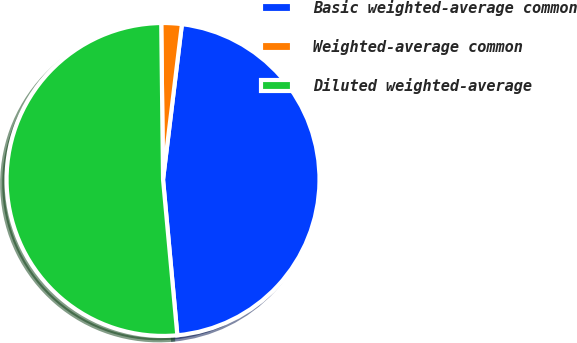Convert chart to OTSL. <chart><loc_0><loc_0><loc_500><loc_500><pie_chart><fcel>Basic weighted-average common<fcel>Weighted-average common<fcel>Diluted weighted-average<nl><fcel>46.61%<fcel>2.11%<fcel>51.27%<nl></chart> 